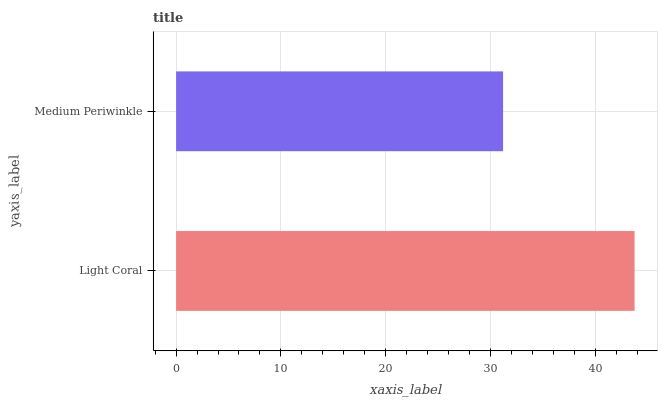Is Medium Periwinkle the minimum?
Answer yes or no. Yes. Is Light Coral the maximum?
Answer yes or no. Yes. Is Medium Periwinkle the maximum?
Answer yes or no. No. Is Light Coral greater than Medium Periwinkle?
Answer yes or no. Yes. Is Medium Periwinkle less than Light Coral?
Answer yes or no. Yes. Is Medium Periwinkle greater than Light Coral?
Answer yes or no. No. Is Light Coral less than Medium Periwinkle?
Answer yes or no. No. Is Light Coral the high median?
Answer yes or no. Yes. Is Medium Periwinkle the low median?
Answer yes or no. Yes. Is Medium Periwinkle the high median?
Answer yes or no. No. Is Light Coral the low median?
Answer yes or no. No. 